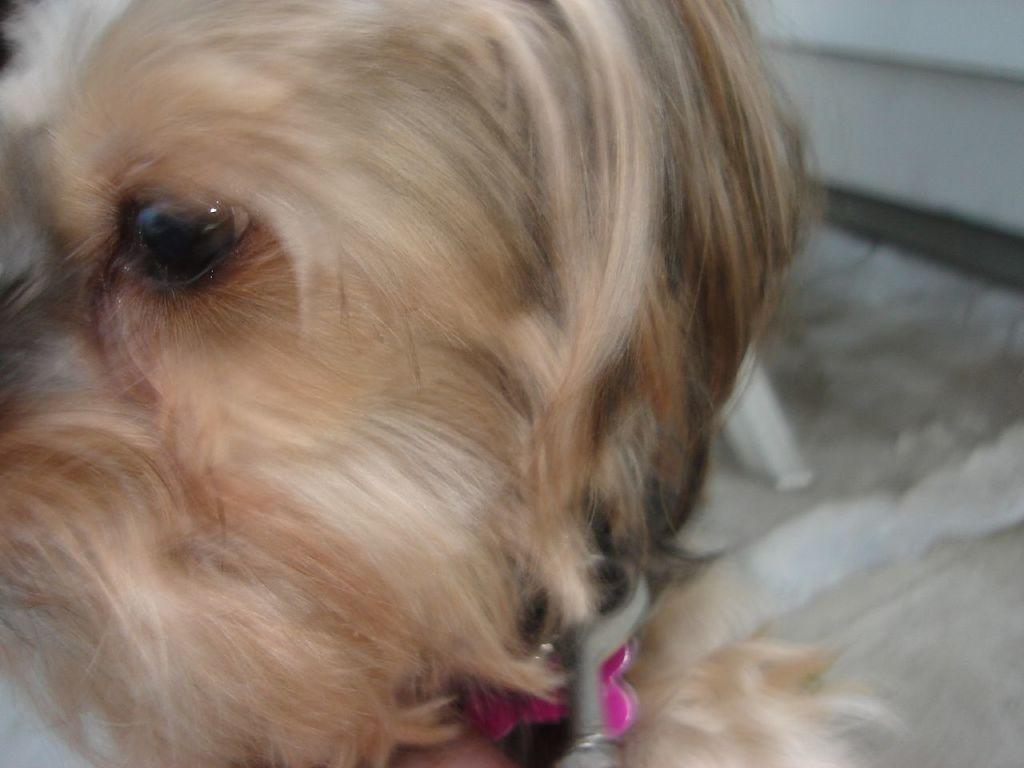What animal can be seen in the image? There is a dog in the image. Can you describe the background of the image? The background of the image is blurry. Reasoning: Let's think step by identifying the main subject in the image, which is the dog. Then, we focus on the background of the image, which is described as blurry. We avoid asking questions that cannot be answered definitively based on the provided facts. Absurd Question/Answer: What type of oil is being used by the dog in the image? There is no oil present in the image, and the dog is not using any oil. 